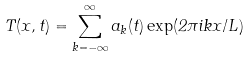<formula> <loc_0><loc_0><loc_500><loc_500>T ( x , t ) = \sum _ { k = - \infty } ^ { \infty } a _ { k } ( t ) \exp ( 2 \pi i k x / L )</formula> 